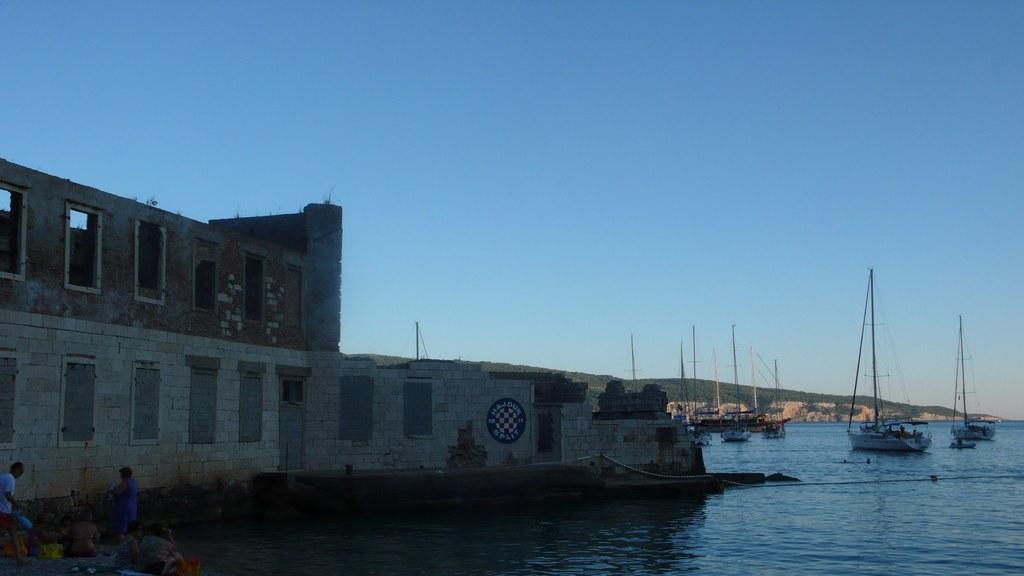Describe this image in one or two sentences. In this image there is a big building beside the river, in which there are so many boats and behind that there is a mountain, also there are people sitting at the bank of river. 